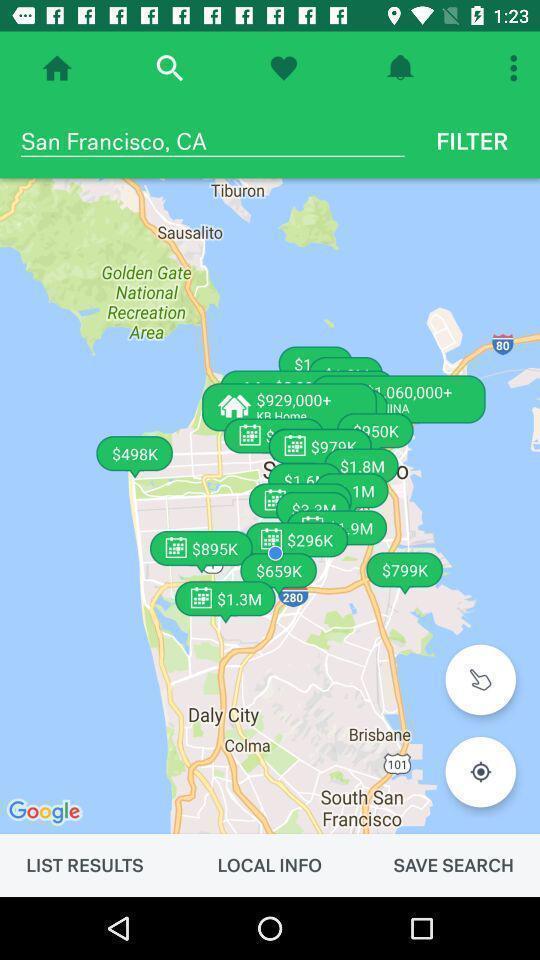Provide a description of this screenshot. Page showing search bar to find location. 